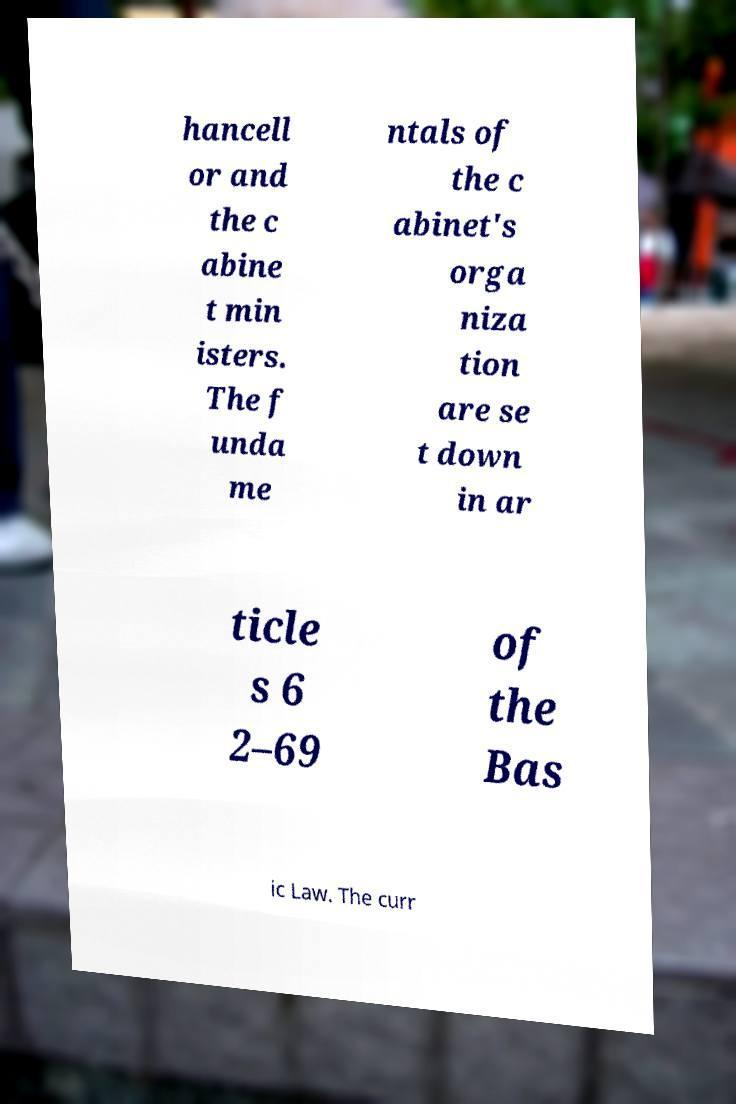What messages or text are displayed in this image? I need them in a readable, typed format. hancell or and the c abine t min isters. The f unda me ntals of the c abinet's orga niza tion are se t down in ar ticle s 6 2–69 of the Bas ic Law. The curr 